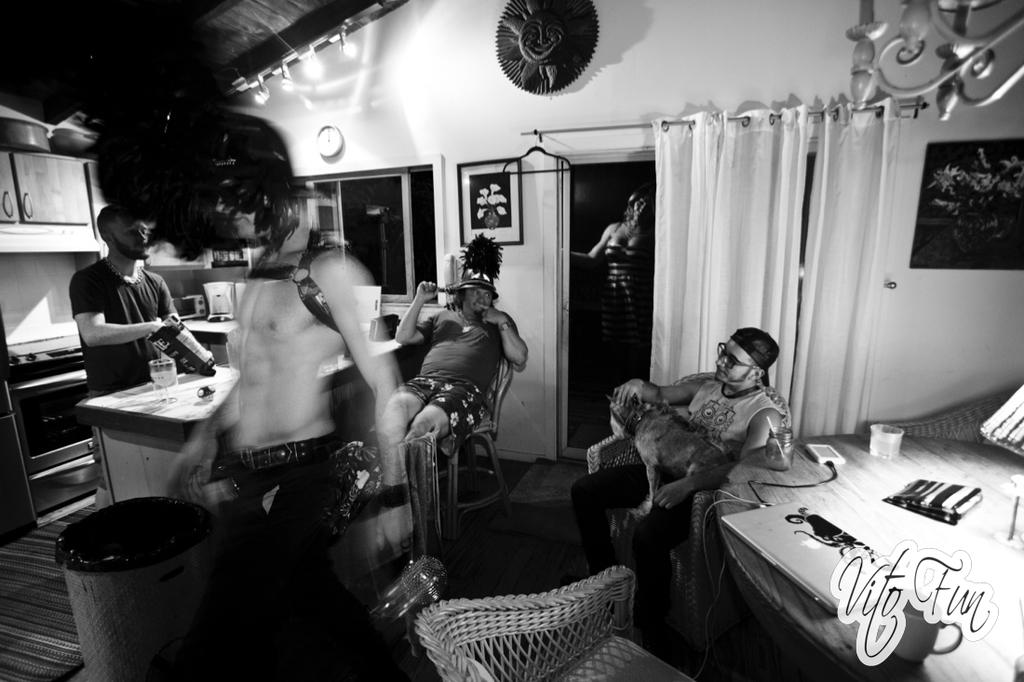How many people are in the image? There are five persons in the image. What can be seen on the table in the image? There is a laptop and a cup on the table. What is the person sitting on in the image? The person is sitting on a chair. What is the person holding in the image? The person is holding a dog. What is on the floor in the image? There is a bin on the floor. What is the purpose of the sand in the image? There is no sand present in the image. Does the dog have any visible fangs in the image? The image does not show the dog's teeth, so it cannot be determined if there are any visible fangs. 